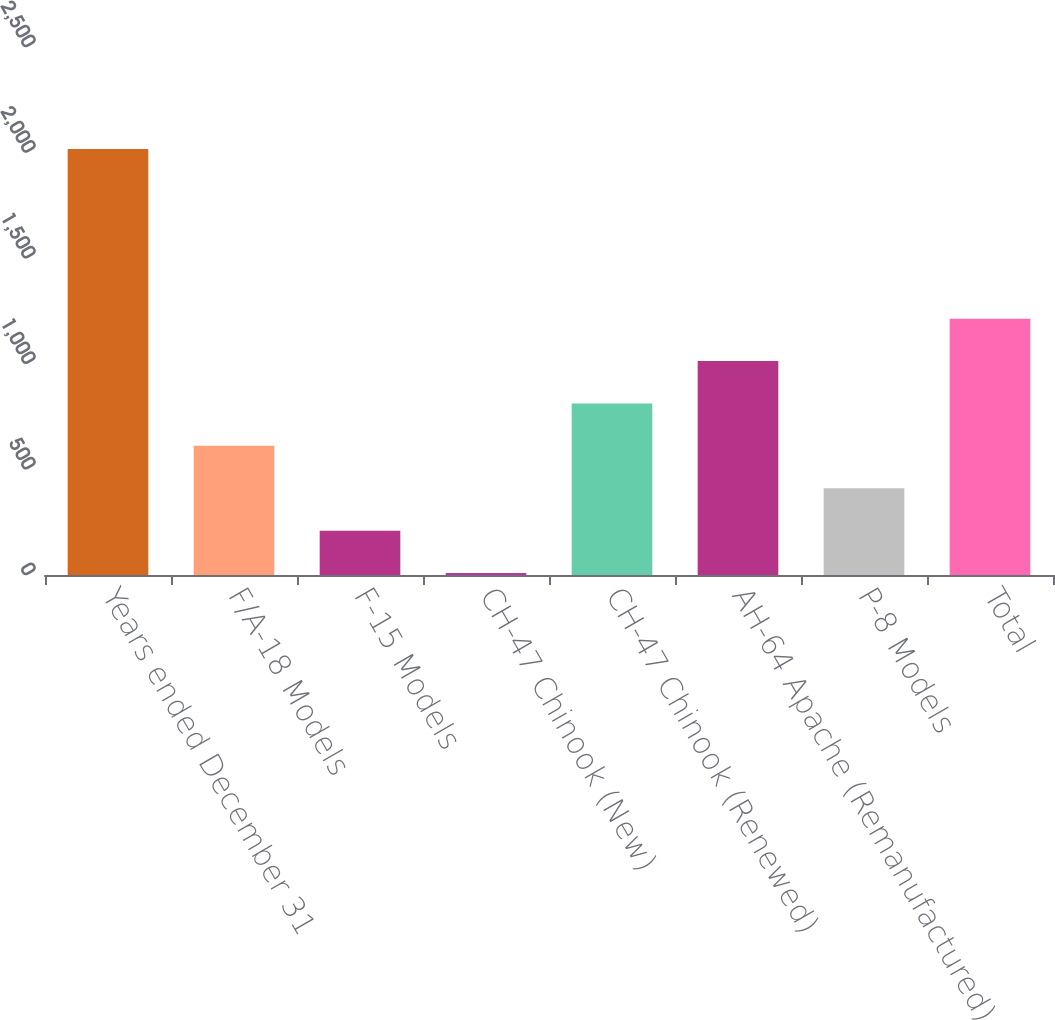<chart> <loc_0><loc_0><loc_500><loc_500><bar_chart><fcel>Years ended December 31<fcel>F/A-18 Models<fcel>F-15 Models<fcel>CH-47 Chinook (New)<fcel>CH-47 Chinook (Renewed)<fcel>AH-64 Apache (Remanufactured)<fcel>P-8 Models<fcel>Total<nl><fcel>2017<fcel>611.4<fcel>209.8<fcel>9<fcel>812.2<fcel>1013<fcel>410.6<fcel>1213.8<nl></chart> 